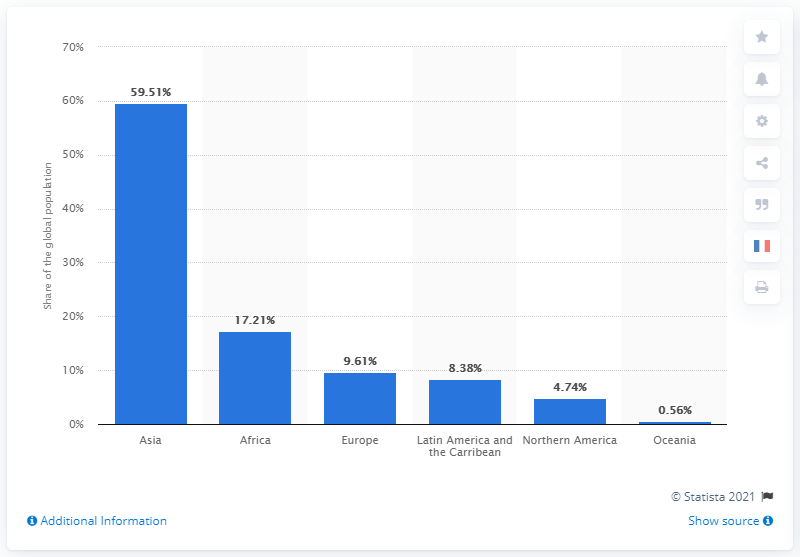Mention a couple of crucial points in this snapshot. As of 2020, it is estimated that 59.51% of the global population is living in Asia. 